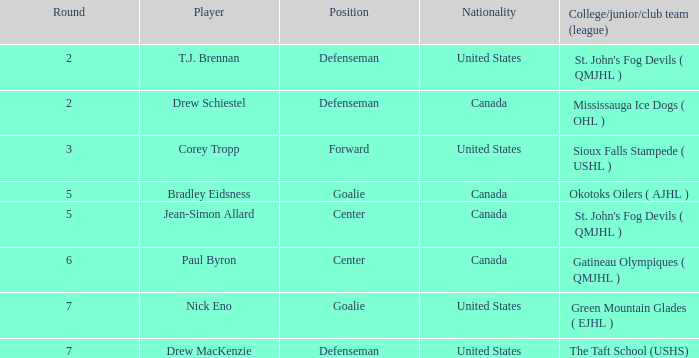What is the nationality of the goalie in Round 7? United States. 